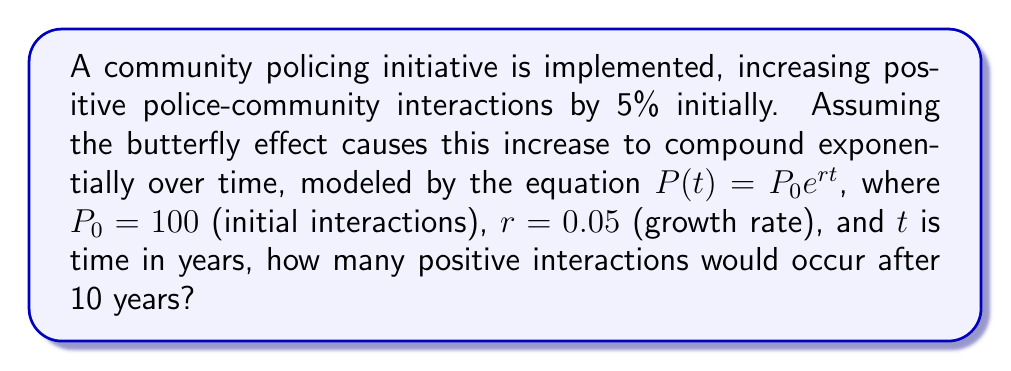Show me your answer to this math problem. To solve this problem, we'll use the given equation and values:

1. The equation: $P(t) = P_0 e^{rt}$
2. Given values: $P_0 = 100$, $r = 0.05$, $t = 10$

Step 1: Substitute the values into the equation:
$P(10) = 100 e^{0.05 \cdot 10}$

Step 2: Simplify the exponent:
$P(10) = 100 e^{0.5}$

Step 3: Calculate $e^{0.5}$ (using a calculator):
$e^{0.5} \approx 1.6487$

Step 4: Multiply by the initial value:
$P(10) = 100 \cdot 1.6487 \approx 164.87$

Step 5: Round to the nearest whole number, as we're dealing with interactions:
$P(10) \approx 165$

Therefore, after 10 years, there would be approximately 165 positive police-community interactions.
Answer: 165 interactions 